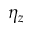Convert formula to latex. <formula><loc_0><loc_0><loc_500><loc_500>\eta _ { z }</formula> 